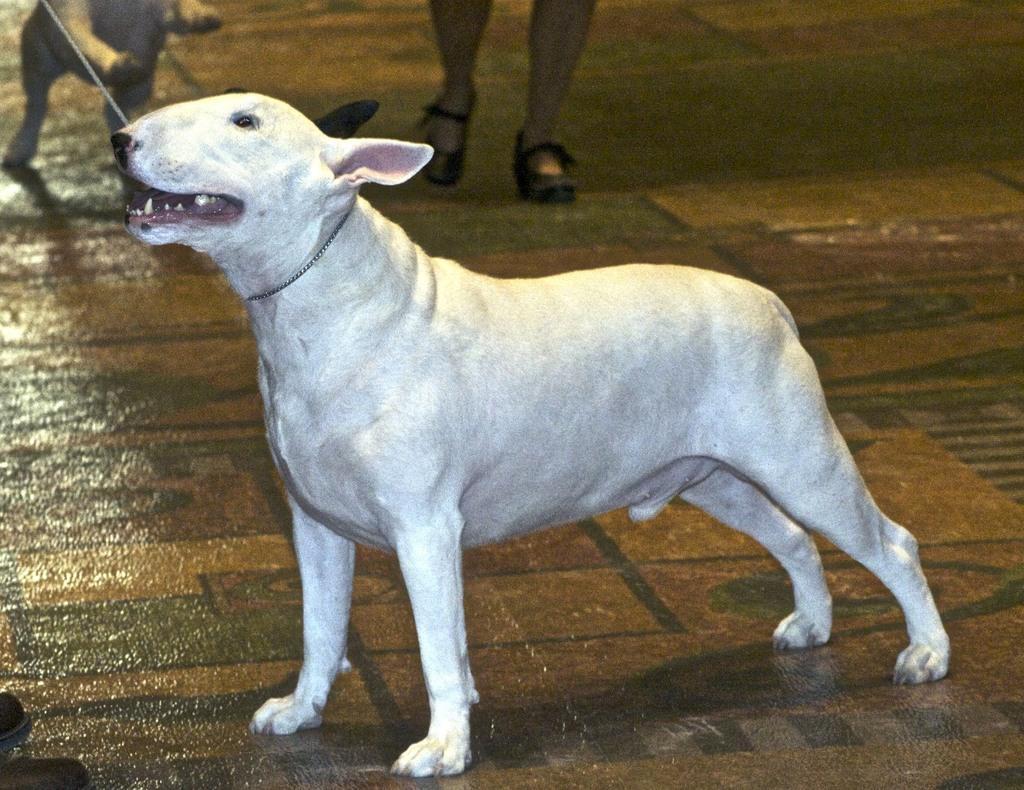Could you give a brief overview of what you see in this image? This picture shows a dog and we see another dog on the side and we see human legs and a dog is white in color. 